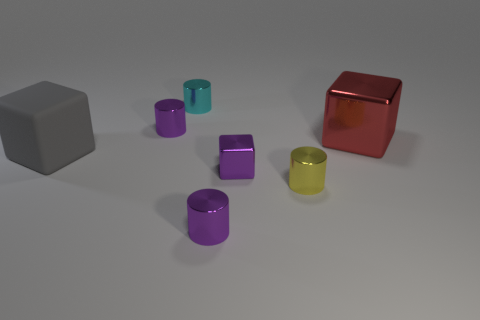Subtract 1 cylinders. How many cylinders are left? 3 Add 1 tiny shiny cylinders. How many objects exist? 8 Subtract all green cylinders. Subtract all cyan blocks. How many cylinders are left? 4 Subtract all cubes. How many objects are left? 4 Add 6 cyan cylinders. How many cyan cylinders exist? 7 Subtract 1 red cubes. How many objects are left? 6 Subtract all tiny metallic cubes. Subtract all purple shiny cylinders. How many objects are left? 4 Add 6 tiny metallic blocks. How many tiny metallic blocks are left? 7 